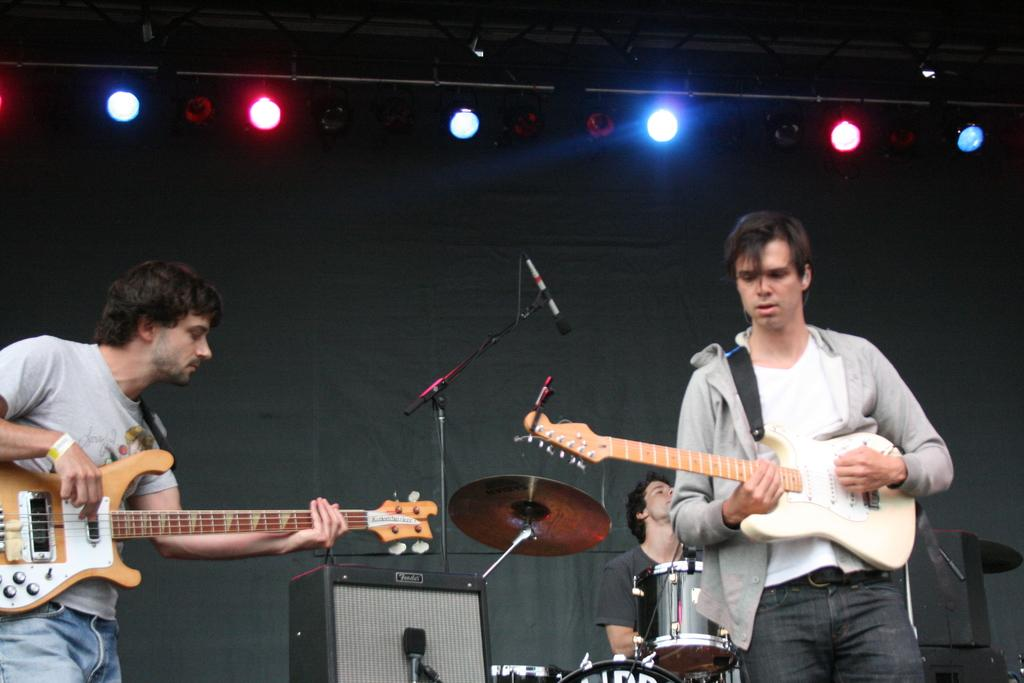What are the two people in the image doing? The two people in the image are standing and playing guitars. What object is present for amplifying sound? There is a microphone with a stand in the image. Can you describe the person in the background? There is a man sitting in the background. What else can be seen in the background? There is a musical instrument in the background. What can be observed about the lighting in the image? There are lights visible in the image. What is the level of anger displayed by the musical instruments in the image? There is no indication of anger in the image, as musical instruments do not have emotions. What type of scene is depicted in the image? The image does not depict a specific scene; it shows two people playing guitars, a microphone with a stand, a man sitting in the background, a musical instrument in the background, and lights. 